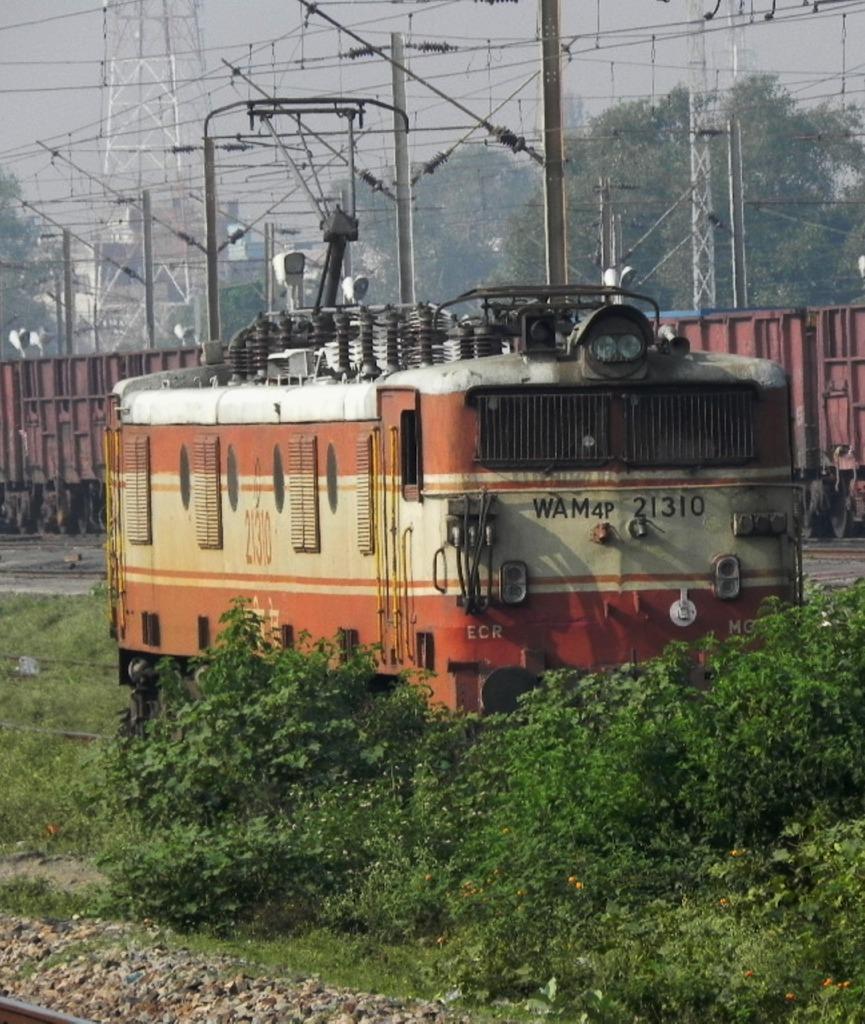How would you summarize this image in a sentence or two? At the bottom of the picture, we see the trees and stones. In front of the picture, we see a train engine. Behind that, we see the goods train is moving on the railway tracks. There are electric poles, wires, trees and a tower in the background. 